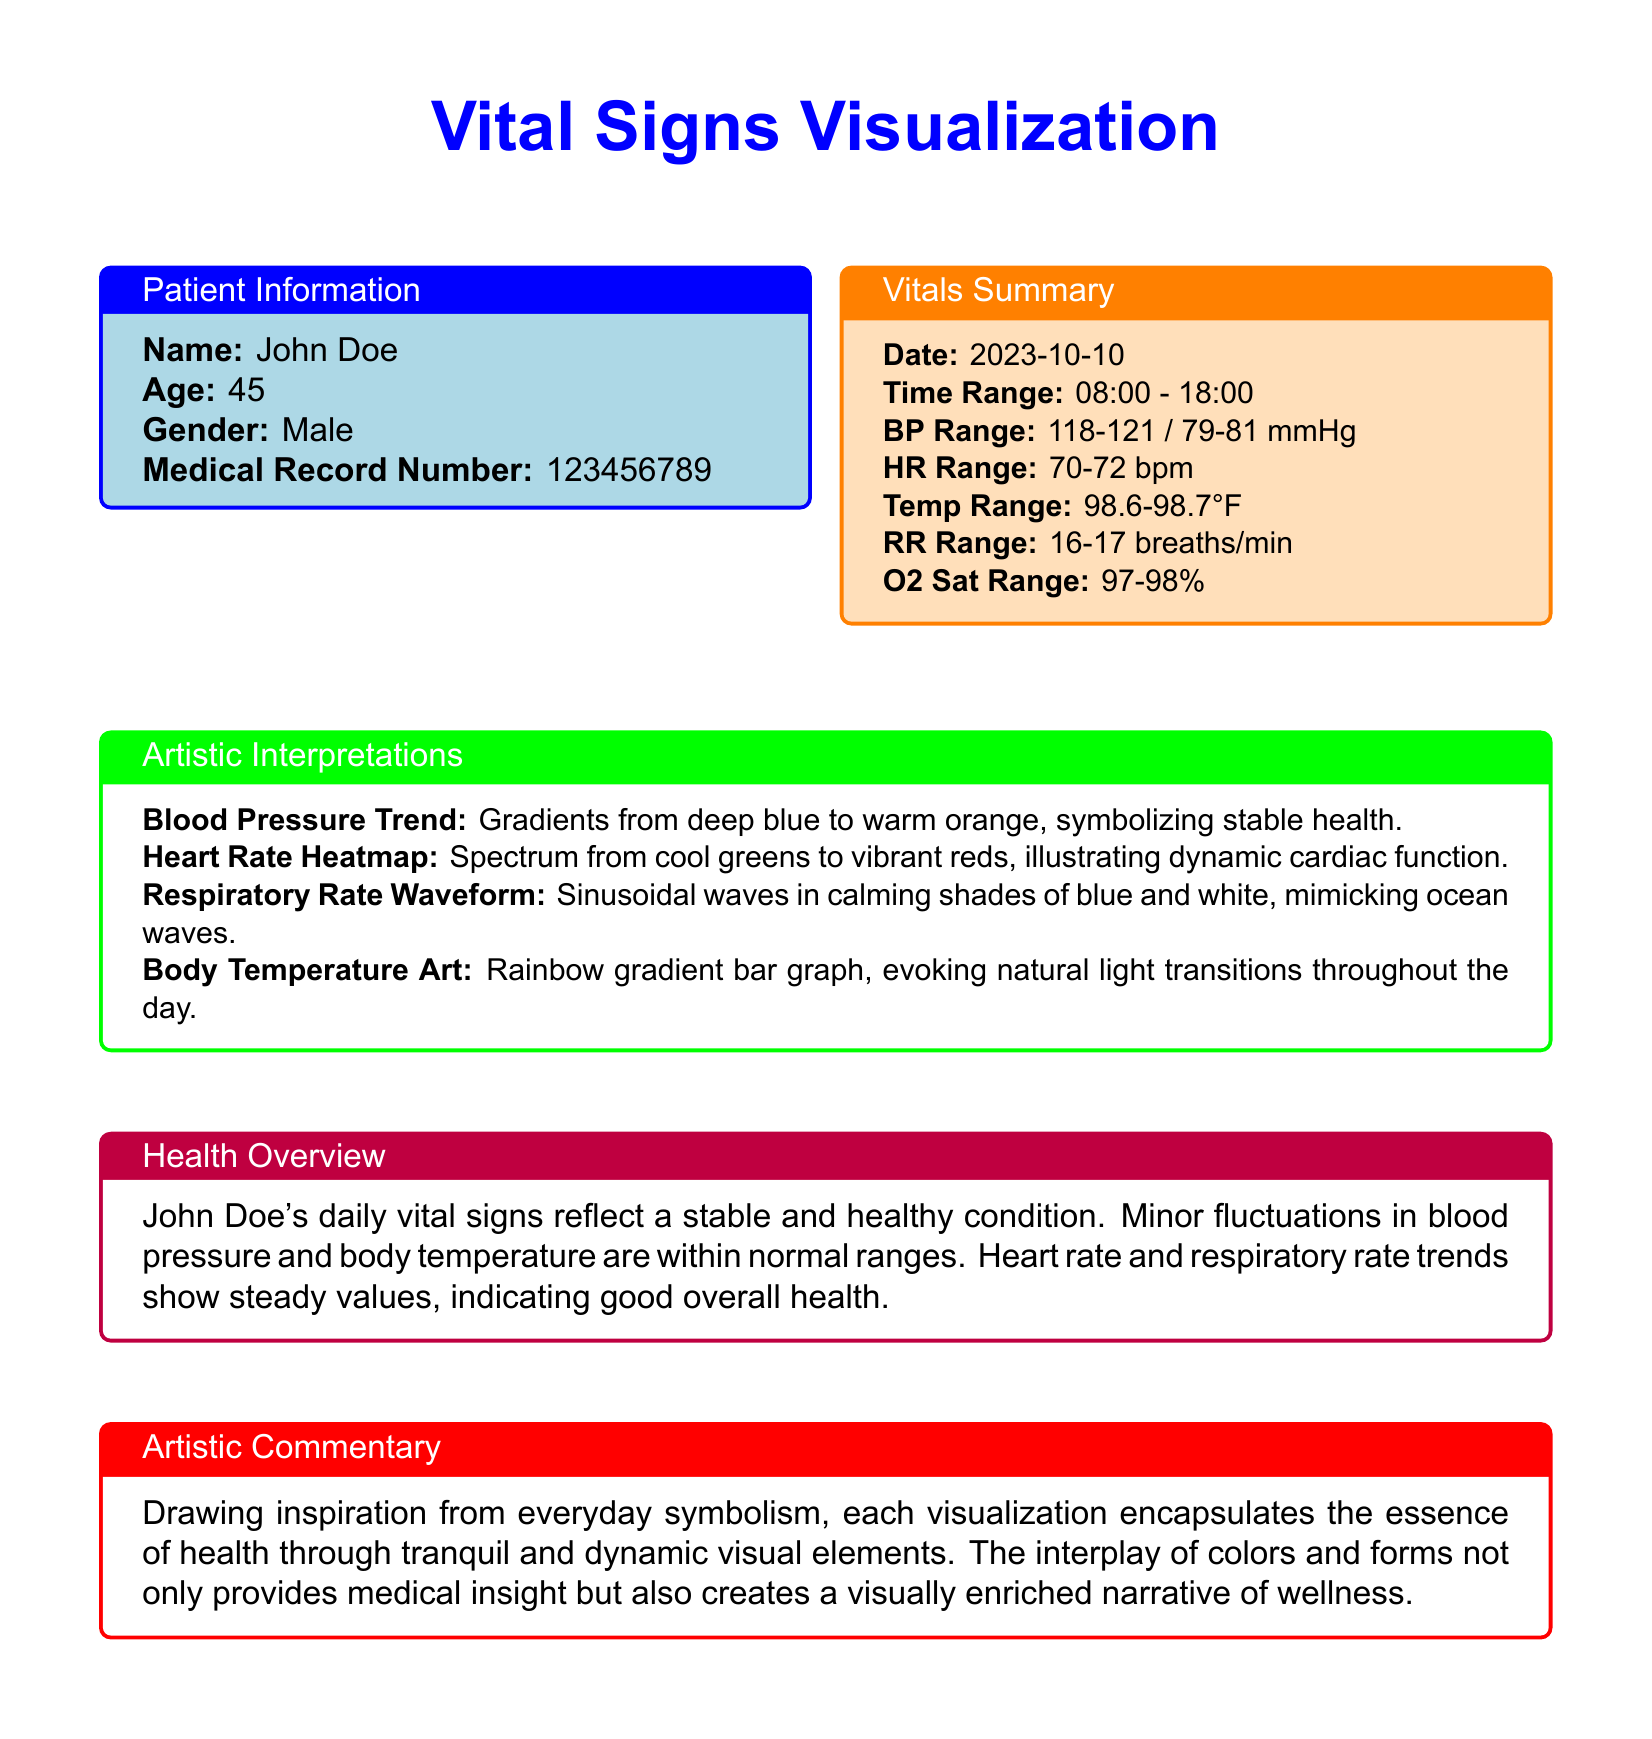What is the patient's name? The patient's name is provided in the patient information section.
Answer: John Doe What is the age of the patient? The age of the patient is stated in the patient information box.
Answer: 45 What is the medical record number? The medical record number can be found in the patient information section.
Answer: 123456789 What is the systolic blood pressure range? The systolic blood pressure range is specified in the vitals summary.
Answer: 118-121 mmHg What does the heart rate heatmap illustrate? The artistic interpretations section provides an explanation of the heart rate heatmap.
Answer: Dynamic cardiac function What color represents stable health in blood pressure visualization? The artistic interpretations describe the color gradient for blood pressure.
Answer: Deep blue to warm orange What does the respiratory rate waveform resemble? The artistic interpretations provide a description of the respiratory rate visualization.
Answer: Ocean waves What is the trend in John Doe's daily vital signs? The health overview summarizes the general condition of the patient's vital signs.
Answer: Stable and healthy condition What does the rainbow gradient bar graph represent? The artistic interpretations section explains what the body temperature art visualizes.
Answer: Natural light transitions throughout the day 